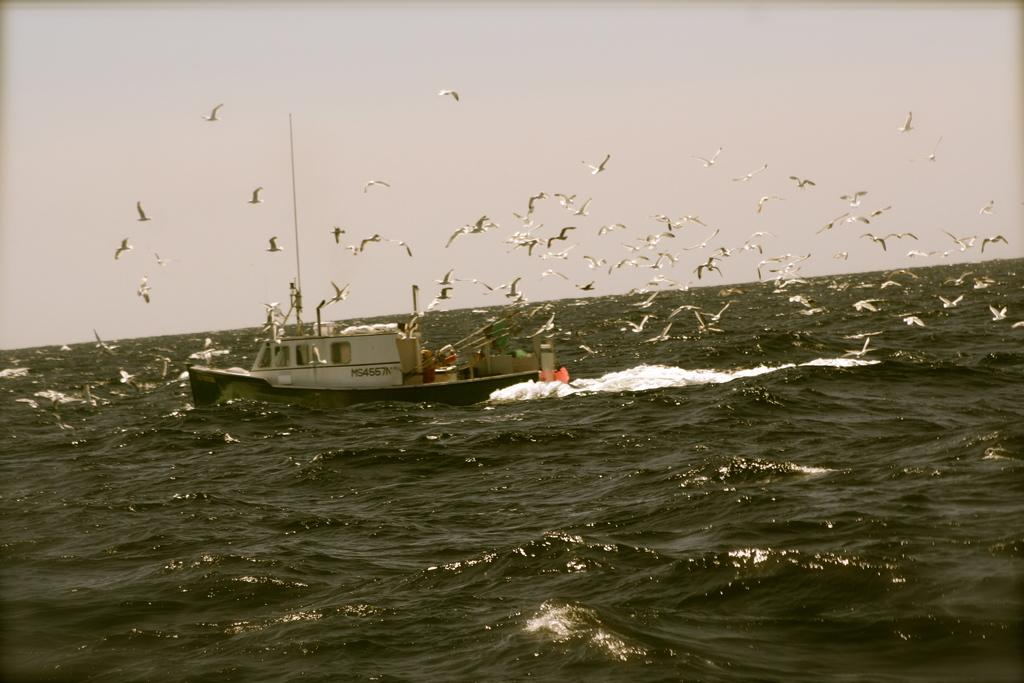What is the main subject of the image? The main subject of the image is water. What is located on the water in the image? There is a boat on the water in the image. What is visible at the top of the image? The sky is visible at the top of the image. What else can be seen in the sky? There are birds flying in the sky. Can you find the receipt for the basket in the image? There is no basket or receipt present in the image. 